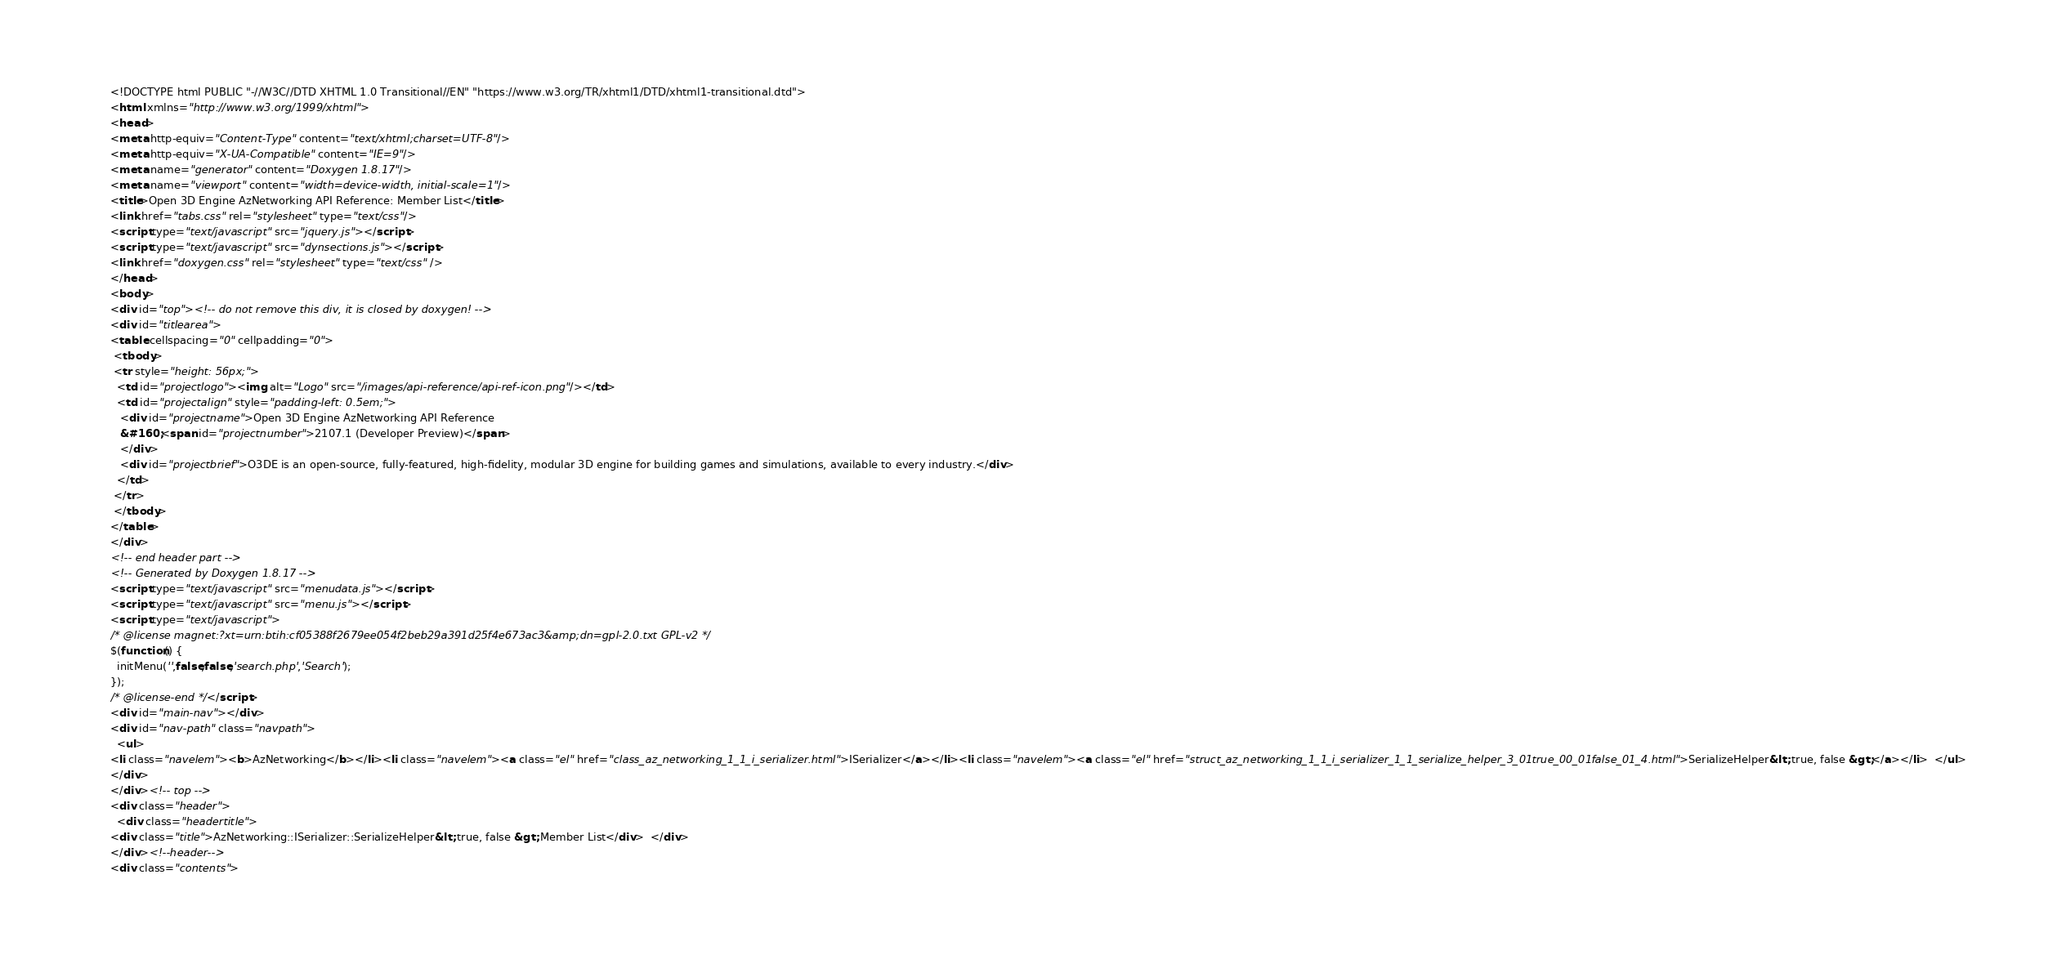<code> <loc_0><loc_0><loc_500><loc_500><_HTML_><!DOCTYPE html PUBLIC "-//W3C//DTD XHTML 1.0 Transitional//EN" "https://www.w3.org/TR/xhtml1/DTD/xhtml1-transitional.dtd">
<html xmlns="http://www.w3.org/1999/xhtml">
<head>
<meta http-equiv="Content-Type" content="text/xhtml;charset=UTF-8"/>
<meta http-equiv="X-UA-Compatible" content="IE=9"/>
<meta name="generator" content="Doxygen 1.8.17"/>
<meta name="viewport" content="width=device-width, initial-scale=1"/>
<title>Open 3D Engine AzNetworking API Reference: Member List</title>
<link href="tabs.css" rel="stylesheet" type="text/css"/>
<script type="text/javascript" src="jquery.js"></script>
<script type="text/javascript" src="dynsections.js"></script>
<link href="doxygen.css" rel="stylesheet" type="text/css" />
</head>
<body>
<div id="top"><!-- do not remove this div, it is closed by doxygen! -->
<div id="titlearea">
<table cellspacing="0" cellpadding="0">
 <tbody>
 <tr style="height: 56px;">
  <td id="projectlogo"><img alt="Logo" src="/images/api-reference/api-ref-icon.png"/></td>
  <td id="projectalign" style="padding-left: 0.5em;">
   <div id="projectname">Open 3D Engine AzNetworking API Reference
   &#160;<span id="projectnumber">2107.1 (Developer Preview)</span>
   </div>
   <div id="projectbrief">O3DE is an open-source, fully-featured, high-fidelity, modular 3D engine for building games and simulations, available to every industry.</div>
  </td>
 </tr>
 </tbody>
</table>
</div>
<!-- end header part -->
<!-- Generated by Doxygen 1.8.17 -->
<script type="text/javascript" src="menudata.js"></script>
<script type="text/javascript" src="menu.js"></script>
<script type="text/javascript">
/* @license magnet:?xt=urn:btih:cf05388f2679ee054f2beb29a391d25f4e673ac3&amp;dn=gpl-2.0.txt GPL-v2 */
$(function() {
  initMenu('',false,false,'search.php','Search');
});
/* @license-end */</script>
<div id="main-nav"></div>
<div id="nav-path" class="navpath">
  <ul>
<li class="navelem"><b>AzNetworking</b></li><li class="navelem"><a class="el" href="class_az_networking_1_1_i_serializer.html">ISerializer</a></li><li class="navelem"><a class="el" href="struct_az_networking_1_1_i_serializer_1_1_serialize_helper_3_01true_00_01false_01_4.html">SerializeHelper&lt; true, false &gt;</a></li>  </ul>
</div>
</div><!-- top -->
<div class="header">
  <div class="headertitle">
<div class="title">AzNetworking::ISerializer::SerializeHelper&lt; true, false &gt; Member List</div>  </div>
</div><!--header-->
<div class="contents">
</code> 